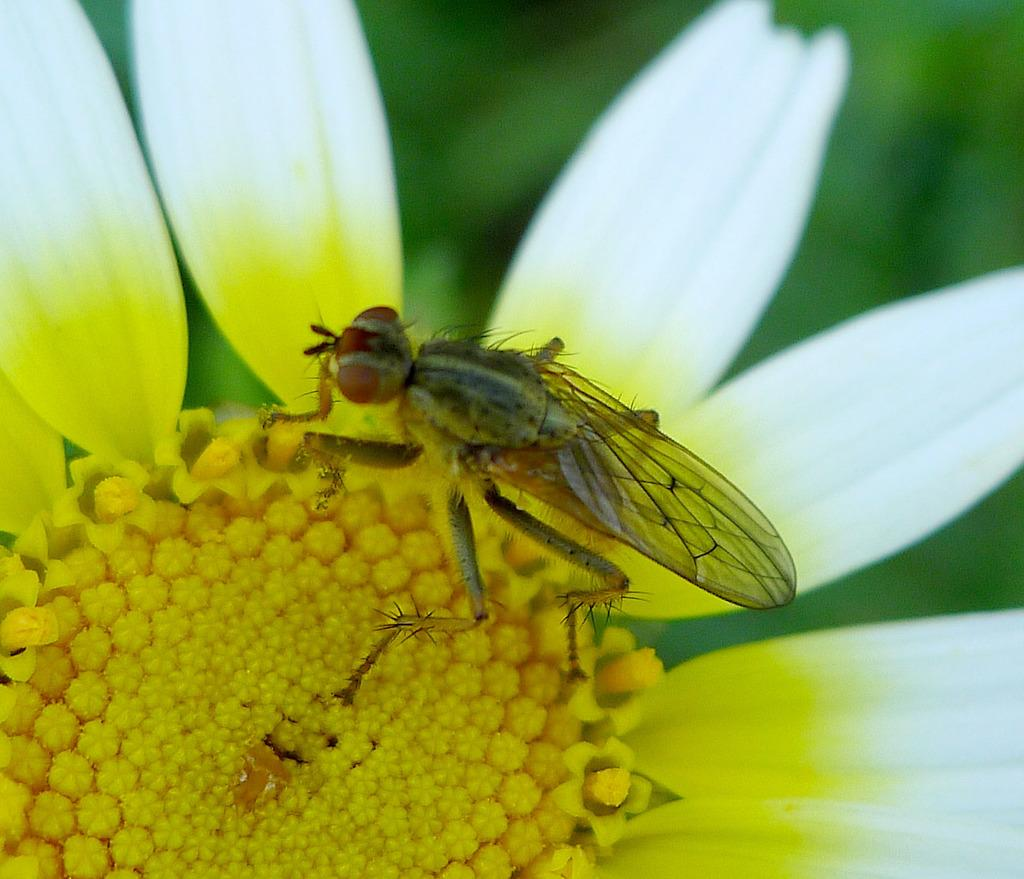What type of insect is present in the image? There is a house fly in the image. Where is the house fly located? The house fly is on a white flower. Can you describe the background of the image? The background of the image is blurry. What type of food is the house fly preparing in the image? There is no indication in the image that the house fly is preparing any food. 